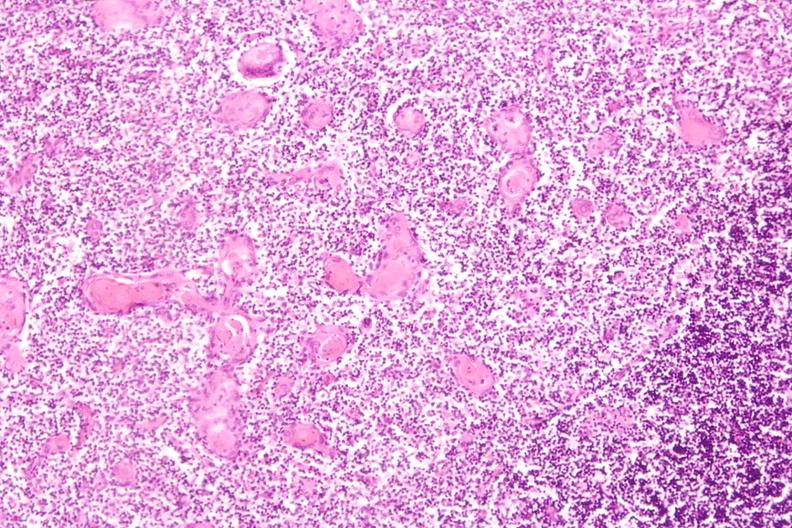do retroperitoneum induce involution in baby with hyaline membrane disease?
Answer the question using a single word or phrase. No 